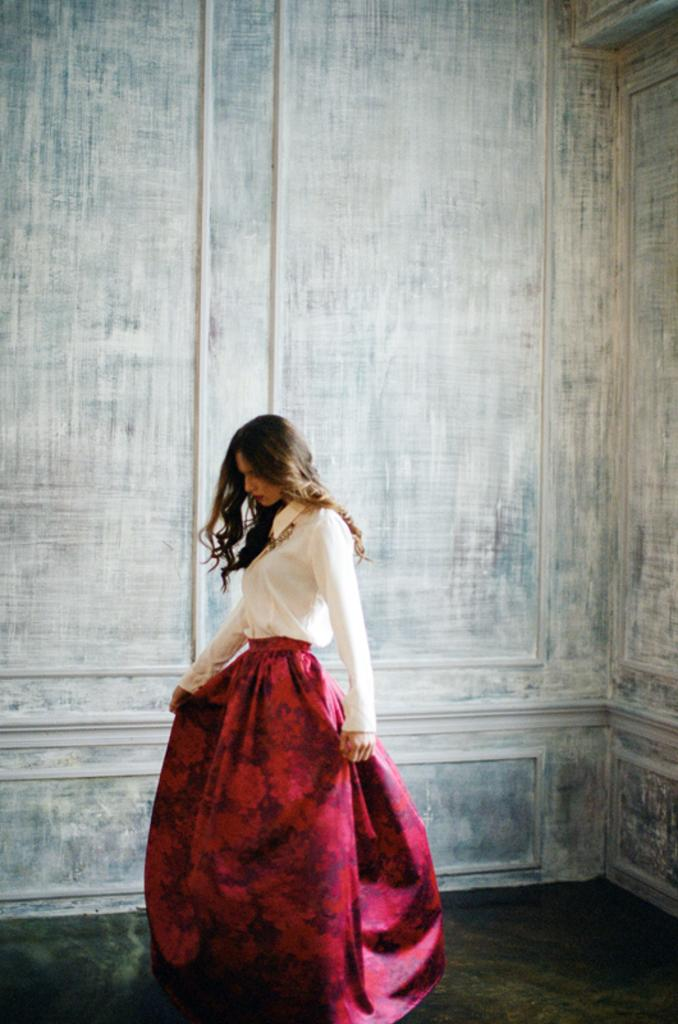Where was the image taken? The image was taken inside a room. What is the main subject in the image? There is a woman standing in the middle of the image. What is the woman standing on? The woman is standing on the floor. Can you describe the floor in the image? There is a floor visible in the background of the image. What type of fuel is being used by the woman in the image? There is no indication in the image that the woman is using any type of fuel. 